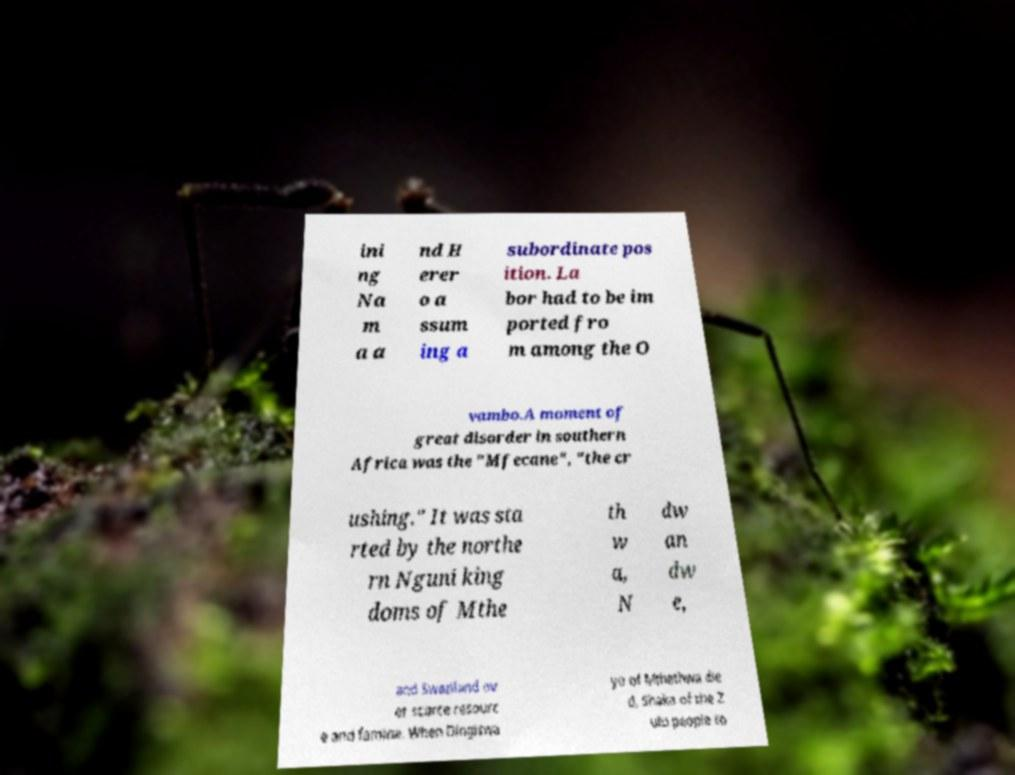Please read and relay the text visible in this image. What does it say? ini ng Na m a a nd H erer o a ssum ing a subordinate pos ition. La bor had to be im ported fro m among the O vambo.A moment of great disorder in southern Africa was the "Mfecane", "the cr ushing." It was sta rted by the northe rn Nguni king doms of Mthe th w a, N dw an dw e, and Swaziland ov er scarce resourc e and famine. When Dingiswa yo of Mthethwa die d, Shaka of the Z ulu people to 